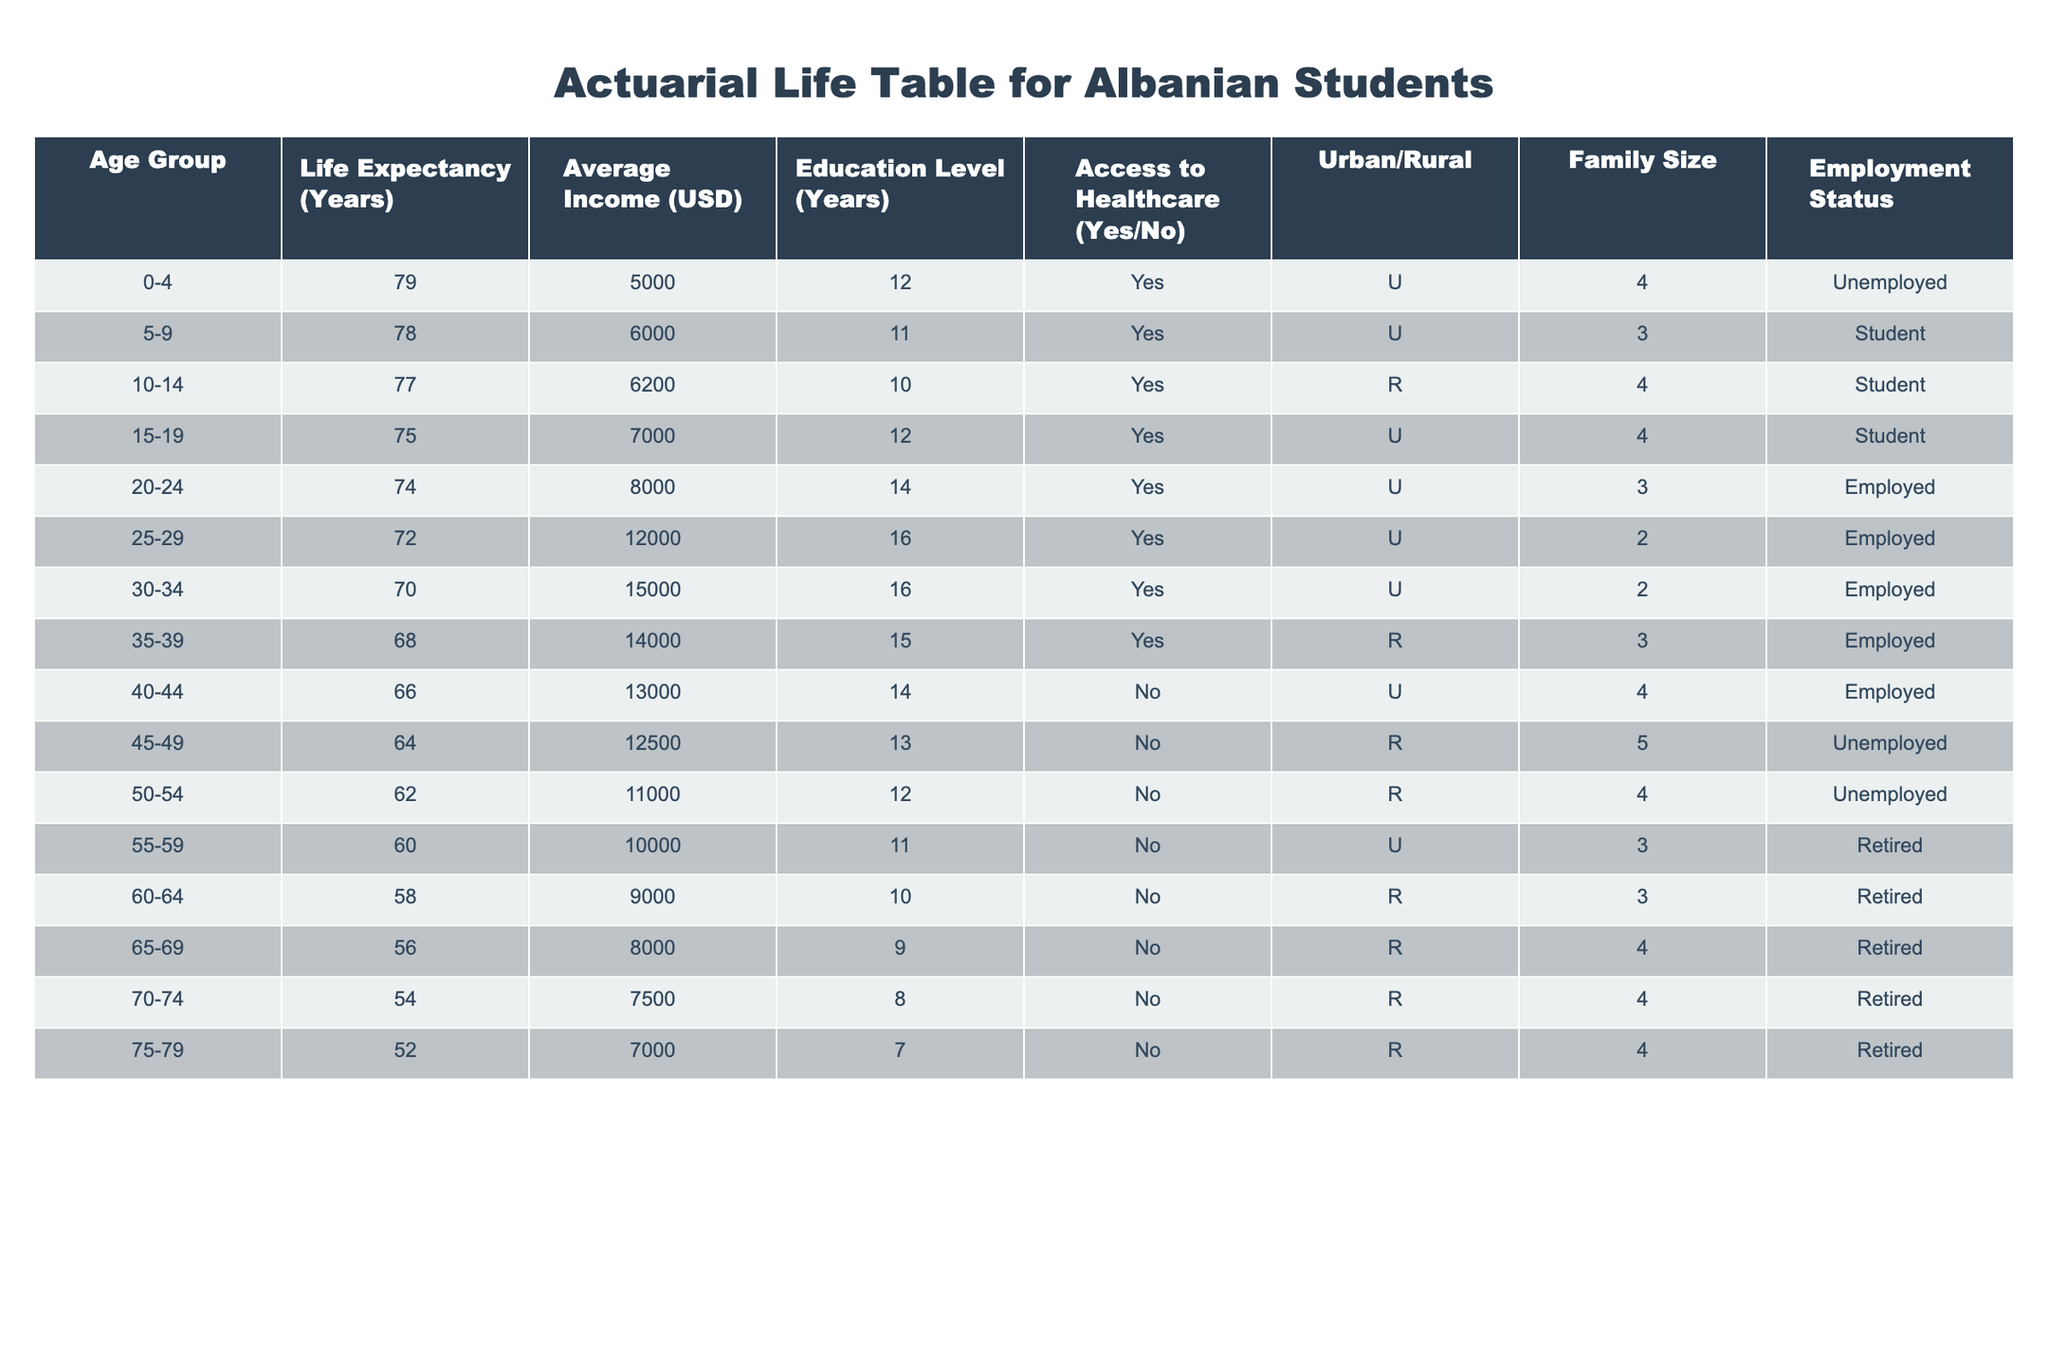What is the life expectancy for the age group 30-34? The table shows that for the age group 30-34, the life expectancy is listed directly as 70 years.
Answer: 70 How many years of education do individuals aged 20-24 have on average? According to the table, individuals in the age group 20-24 have an average of 14 years of education.
Answer: 14 What is the average income for students aged 15-19? The average income for students in the age group 15-19 is 7,000 USD, as noted in the corresponding row of the table.
Answer: 7000 Are there any age groups with no access to healthcare? The table indicates that individuals aged 40-44, 45-49, 50-54, 55-59, 60-64, and 65-69 do not have access to healthcare, hence the answer is yes.
Answer: Yes What is the total family size for the age groups 50-54 and 55-59? For the age group 50-54, the family size is 4 and for 55-59 is 3. The sum is 4 + 3 = 7.
Answer: 7 What is the difference in life expectancy between the age groups 0-4 and 75-79? The life expectancy for the age group 0-4 is 79 years and for 75-79 it is 52 years. The difference is 79 - 52 = 27 years.
Answer: 27 What percentage of individuals aged 60-64 have access to healthcare? Individuals aged 60-64 do not have access to healthcare as indicated in the table. There is only one entry for this age group, thus the percentage is 0%.
Answer: 0% How many employed individuals are there in the age group of 25-29? The table shows that there is 1 entry for the age group 25-29, and that individual is employed, thus the answer is 1.
Answer: 1 What is the median income for individuals aged 55-59 and 60-64? The income for 55-59 is 10,000 USD and for 60-64 it is 9,000 USD. Arranging these values, the median is the average of the two, (10,000 + 9,000) / 2 = 9,500 USD.
Answer: 9500 